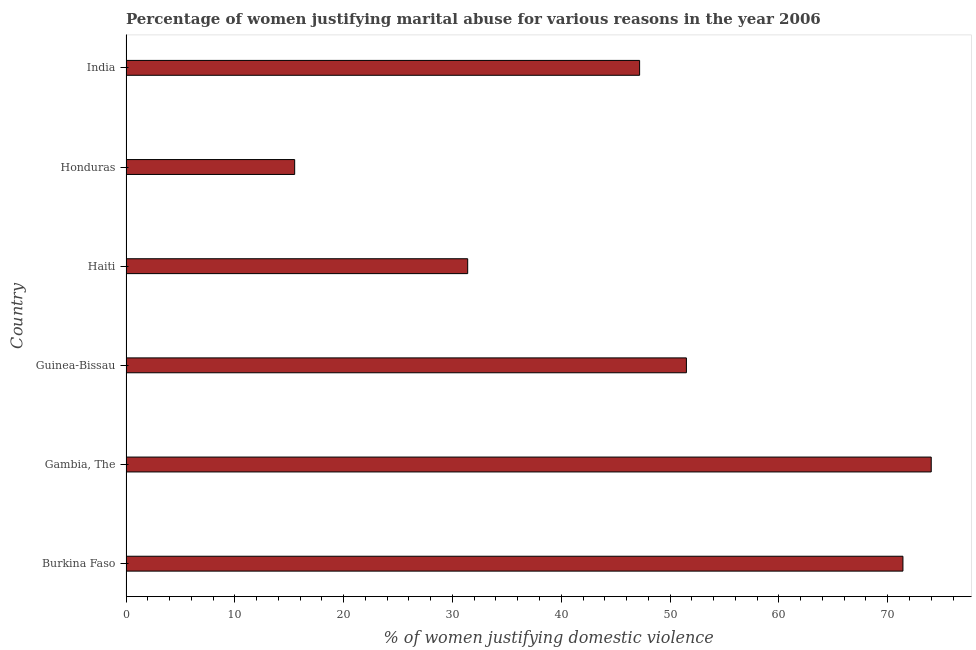What is the title of the graph?
Provide a succinct answer. Percentage of women justifying marital abuse for various reasons in the year 2006. What is the label or title of the X-axis?
Offer a terse response. % of women justifying domestic violence. Across all countries, what is the maximum percentage of women justifying marital abuse?
Ensure brevity in your answer.  74. Across all countries, what is the minimum percentage of women justifying marital abuse?
Offer a terse response. 15.5. In which country was the percentage of women justifying marital abuse maximum?
Your answer should be compact. Gambia, The. In which country was the percentage of women justifying marital abuse minimum?
Offer a very short reply. Honduras. What is the sum of the percentage of women justifying marital abuse?
Give a very brief answer. 291. What is the difference between the percentage of women justifying marital abuse in Gambia, The and India?
Provide a short and direct response. 26.8. What is the average percentage of women justifying marital abuse per country?
Provide a short and direct response. 48.5. What is the median percentage of women justifying marital abuse?
Offer a very short reply. 49.35. In how many countries, is the percentage of women justifying marital abuse greater than 60 %?
Keep it short and to the point. 2. What is the ratio of the percentage of women justifying marital abuse in Haiti to that in Honduras?
Your response must be concise. 2.03. Is the percentage of women justifying marital abuse in Guinea-Bissau less than that in Haiti?
Keep it short and to the point. No. Is the difference between the percentage of women justifying marital abuse in Burkina Faso and Honduras greater than the difference between any two countries?
Keep it short and to the point. No. What is the difference between the highest and the second highest percentage of women justifying marital abuse?
Your answer should be very brief. 2.6. Is the sum of the percentage of women justifying marital abuse in Burkina Faso and Gambia, The greater than the maximum percentage of women justifying marital abuse across all countries?
Provide a short and direct response. Yes. What is the difference between the highest and the lowest percentage of women justifying marital abuse?
Your response must be concise. 58.5. In how many countries, is the percentage of women justifying marital abuse greater than the average percentage of women justifying marital abuse taken over all countries?
Provide a short and direct response. 3. How many bars are there?
Your answer should be compact. 6. Are the values on the major ticks of X-axis written in scientific E-notation?
Offer a very short reply. No. What is the % of women justifying domestic violence of Burkina Faso?
Keep it short and to the point. 71.4. What is the % of women justifying domestic violence of Guinea-Bissau?
Offer a very short reply. 51.5. What is the % of women justifying domestic violence in Haiti?
Make the answer very short. 31.4. What is the % of women justifying domestic violence of Honduras?
Offer a terse response. 15.5. What is the % of women justifying domestic violence of India?
Ensure brevity in your answer.  47.2. What is the difference between the % of women justifying domestic violence in Burkina Faso and Guinea-Bissau?
Your response must be concise. 19.9. What is the difference between the % of women justifying domestic violence in Burkina Faso and Honduras?
Make the answer very short. 55.9. What is the difference between the % of women justifying domestic violence in Burkina Faso and India?
Offer a terse response. 24.2. What is the difference between the % of women justifying domestic violence in Gambia, The and Haiti?
Provide a succinct answer. 42.6. What is the difference between the % of women justifying domestic violence in Gambia, The and Honduras?
Offer a terse response. 58.5. What is the difference between the % of women justifying domestic violence in Gambia, The and India?
Your answer should be compact. 26.8. What is the difference between the % of women justifying domestic violence in Guinea-Bissau and Haiti?
Your answer should be compact. 20.1. What is the difference between the % of women justifying domestic violence in Guinea-Bissau and Honduras?
Make the answer very short. 36. What is the difference between the % of women justifying domestic violence in Haiti and Honduras?
Provide a short and direct response. 15.9. What is the difference between the % of women justifying domestic violence in Haiti and India?
Provide a short and direct response. -15.8. What is the difference between the % of women justifying domestic violence in Honduras and India?
Give a very brief answer. -31.7. What is the ratio of the % of women justifying domestic violence in Burkina Faso to that in Guinea-Bissau?
Provide a short and direct response. 1.39. What is the ratio of the % of women justifying domestic violence in Burkina Faso to that in Haiti?
Provide a succinct answer. 2.27. What is the ratio of the % of women justifying domestic violence in Burkina Faso to that in Honduras?
Your answer should be compact. 4.61. What is the ratio of the % of women justifying domestic violence in Burkina Faso to that in India?
Ensure brevity in your answer.  1.51. What is the ratio of the % of women justifying domestic violence in Gambia, The to that in Guinea-Bissau?
Provide a succinct answer. 1.44. What is the ratio of the % of women justifying domestic violence in Gambia, The to that in Haiti?
Ensure brevity in your answer.  2.36. What is the ratio of the % of women justifying domestic violence in Gambia, The to that in Honduras?
Give a very brief answer. 4.77. What is the ratio of the % of women justifying domestic violence in Gambia, The to that in India?
Provide a succinct answer. 1.57. What is the ratio of the % of women justifying domestic violence in Guinea-Bissau to that in Haiti?
Your answer should be compact. 1.64. What is the ratio of the % of women justifying domestic violence in Guinea-Bissau to that in Honduras?
Your answer should be compact. 3.32. What is the ratio of the % of women justifying domestic violence in Guinea-Bissau to that in India?
Make the answer very short. 1.09. What is the ratio of the % of women justifying domestic violence in Haiti to that in Honduras?
Your answer should be compact. 2.03. What is the ratio of the % of women justifying domestic violence in Haiti to that in India?
Provide a succinct answer. 0.67. What is the ratio of the % of women justifying domestic violence in Honduras to that in India?
Offer a terse response. 0.33. 